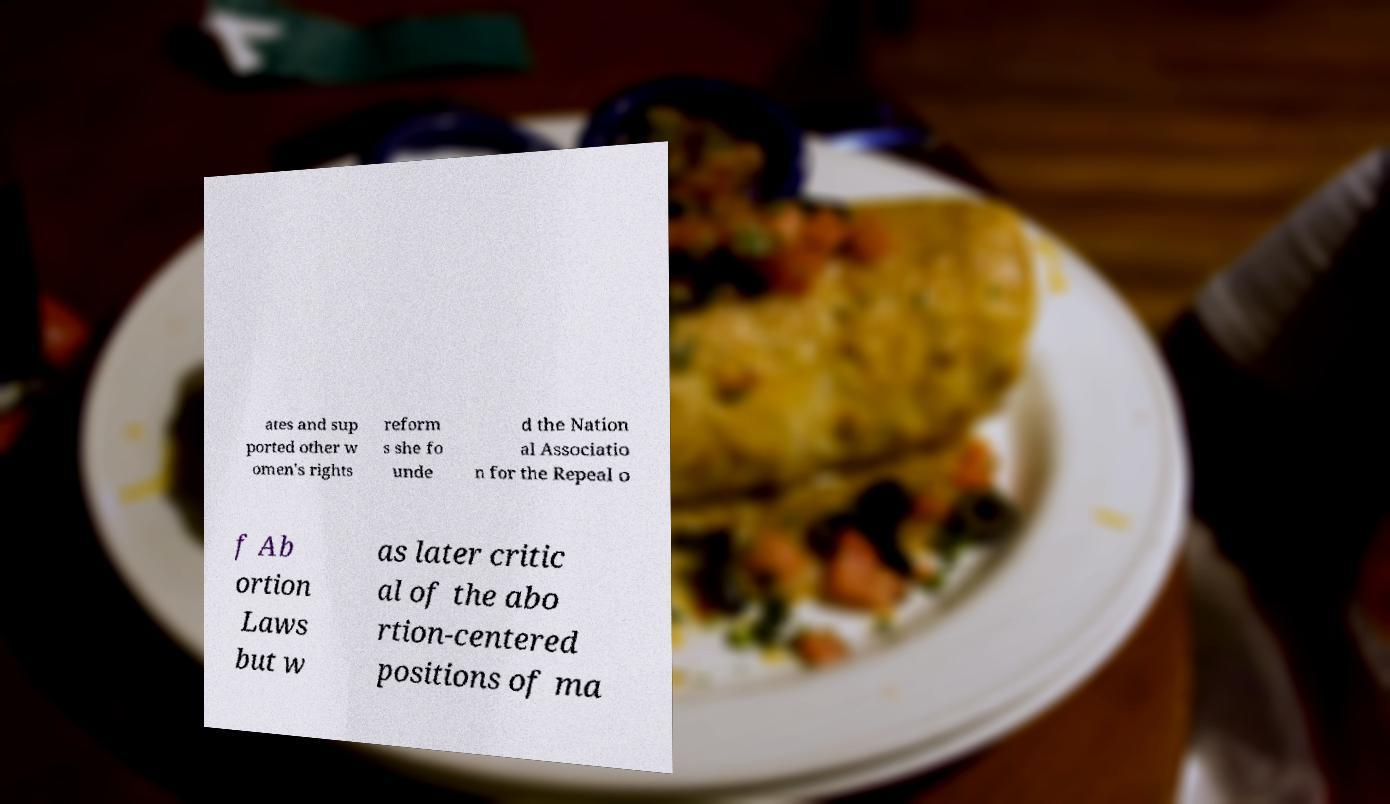Please identify and transcribe the text found in this image. ates and sup ported other w omen's rights reform s she fo unde d the Nation al Associatio n for the Repeal o f Ab ortion Laws but w as later critic al of the abo rtion-centered positions of ma 